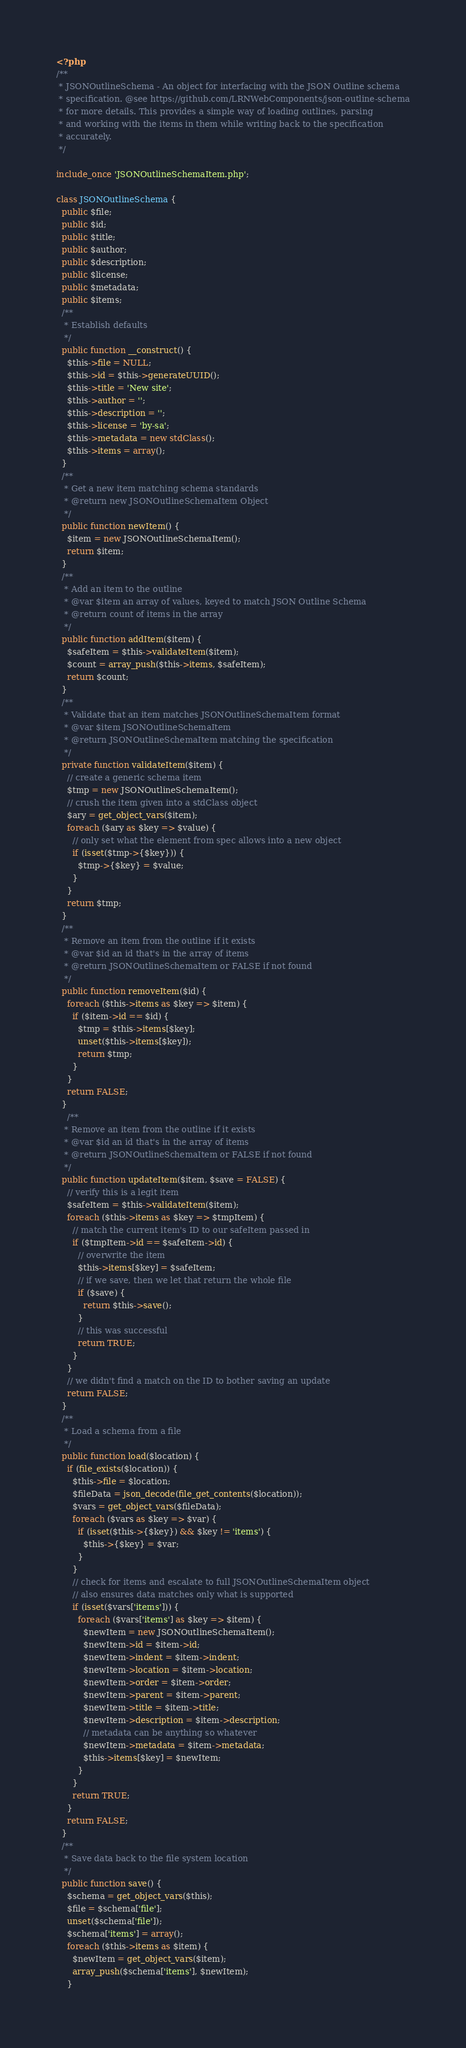<code> <loc_0><loc_0><loc_500><loc_500><_PHP_><?php
/**
 * JSONOutlineSchema - An object for interfacing with the JSON Outline schema
 * specification. @see https://github.com/LRNWebComponents/json-outline-schema
 * for more details. This provides a simple way of loading outlines, parsing
 * and working with the items in them while writing back to the specification
 * accurately.
 */

include_once 'JSONOutlineSchemaItem.php';

class JSONOutlineSchema {
  public $file;
  public $id;
  public $title;
  public $author;
  public $description;
  public $license;
  public $metadata;
  public $items;
  /**
   * Establish defaults
   */
  public function __construct() {
    $this->file = NULL;
    $this->id = $this->generateUUID();
    $this->title = 'New site';
    $this->author = '';
    $this->description = '';
    $this->license = 'by-sa';
    $this->metadata = new stdClass();
    $this->items = array();
  }
  /**
   * Get a new item matching schema standards
   * @return new JSONOutlineSchemaItem Object
   */
  public function newItem() {
    $item = new JSONOutlineSchemaItem();
    return $item;
  }
  /**
   * Add an item to the outline
   * @var $item an array of values, keyed to match JSON Outline Schema
   * @return count of items in the array
   */
  public function addItem($item) {
    $safeItem = $this->validateItem($item);
    $count = array_push($this->items, $safeItem);
    return $count;
  }
  /**
   * Validate that an item matches JSONOutlineSchemaItem format
   * @var $item JSONOutlineSchemaItem
   * @return JSONOutlineSchemaItem matching the specification
   */
  private function validateItem($item) {
    // create a generic schema item
    $tmp = new JSONOutlineSchemaItem();
    // crush the item given into a stdClass object
    $ary = get_object_vars($item);
    foreach ($ary as $key => $value) {
      // only set what the element from spec allows into a new object
      if (isset($tmp->{$key})) {
        $tmp->{$key} = $value;
      }
    }
    return $tmp;
  }
  /**
   * Remove an item from the outline if it exists
   * @var $id an id that's in the array of items
   * @return JSONOutlineSchemaItem or FALSE if not found
   */
  public function removeItem($id) {
    foreach ($this->items as $key => $item) {
      if ($item->id == $id) {
        $tmp = $this->items[$key];
        unset($this->items[$key]);
        return $tmp;
      }
    }
    return FALSE;
  }
    /**
   * Remove an item from the outline if it exists
   * @var $id an id that's in the array of items
   * @return JSONOutlineSchemaItem or FALSE if not found
   */
  public function updateItem($item, $save = FALSE) {
    // verify this is a legit item
    $safeItem = $this->validateItem($item);
    foreach ($this->items as $key => $tmpItem) {
      // match the current item's ID to our safeItem passed in
      if ($tmpItem->id == $safeItem->id) {
        // overwrite the item
        $this->items[$key] = $safeItem;
        // if we save, then we let that return the whole file
        if ($save) {
          return $this->save();
        }
        // this was successful
        return TRUE;
      }
    }
    // we didn't find a match on the ID to bother saving an update
    return FALSE;
  }
  /**
   * Load a schema from a file
   */
  public function load($location) {
    if (file_exists($location)) {
      $this->file = $location;
      $fileData = json_decode(file_get_contents($location));
      $vars = get_object_vars($fileData);
      foreach ($vars as $key => $var) {
        if (isset($this->{$key}) && $key != 'items') {
          $this->{$key} = $var;
        }
      }
      // check for items and escalate to full JSONOutlineSchemaItem object
      // also ensures data matches only what is supported
      if (isset($vars['items'])) {
        foreach ($vars['items'] as $key => $item) {
          $newItem = new JSONOutlineSchemaItem();
          $newItem->id = $item->id;
          $newItem->indent = $item->indent;
          $newItem->location = $item->location;
          $newItem->order = $item->order;
          $newItem->parent = $item->parent;
          $newItem->title = $item->title;
          $newItem->description = $item->description;
          // metadata can be anything so whatever
          $newItem->metadata = $item->metadata;
          $this->items[$key] = $newItem;
        }
      }
      return TRUE;
    }
    return FALSE;
  }
  /**
   * Save data back to the file system location
   */
  public function save() {
    $schema = get_object_vars($this);
    $file = $schema['file'];
    unset($schema['file']);
    $schema['items'] = array();
    foreach ($this->items as $item) {
      $newItem = get_object_vars($item);
      array_push($schema['items'], $newItem);
    }</code> 